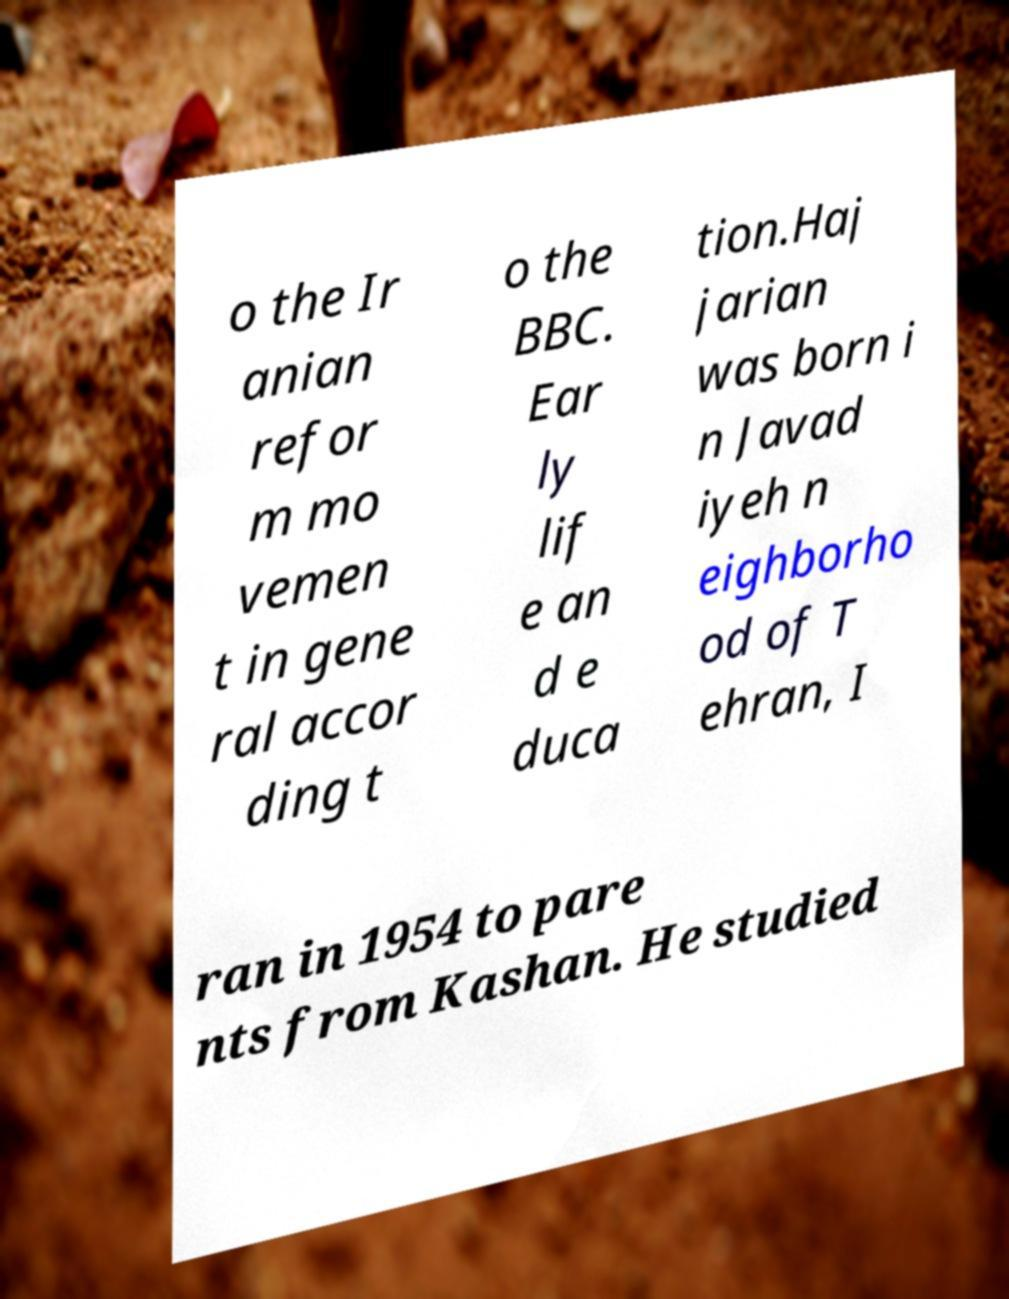For documentation purposes, I need the text within this image transcribed. Could you provide that? o the Ir anian refor m mo vemen t in gene ral accor ding t o the BBC. Ear ly lif e an d e duca tion.Haj jarian was born i n Javad iyeh n eighborho od of T ehran, I ran in 1954 to pare nts from Kashan. He studied 